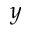Convert formula to latex. <formula><loc_0><loc_0><loc_500><loc_500>y</formula> 